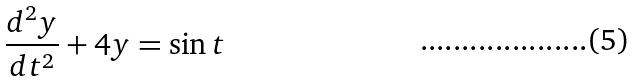<formula> <loc_0><loc_0><loc_500><loc_500>\frac { d ^ { 2 } y } { d t ^ { 2 } } + 4 y = \sin t</formula> 